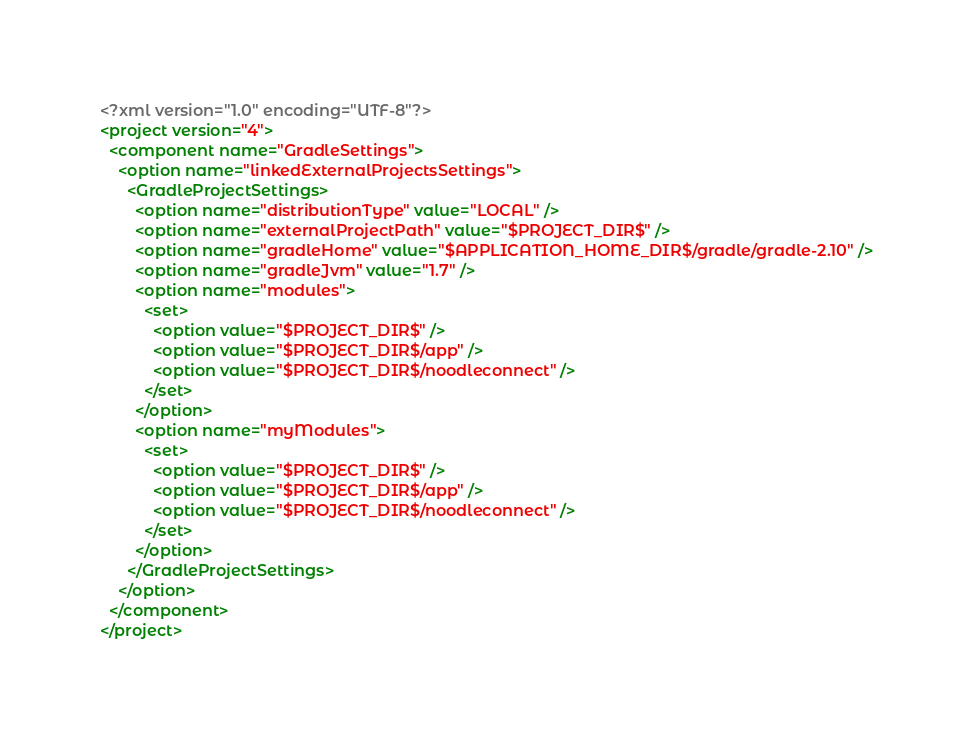<code> <loc_0><loc_0><loc_500><loc_500><_XML_><?xml version="1.0" encoding="UTF-8"?>
<project version="4">
  <component name="GradleSettings">
    <option name="linkedExternalProjectsSettings">
      <GradleProjectSettings>
        <option name="distributionType" value="LOCAL" />
        <option name="externalProjectPath" value="$PROJECT_DIR$" />
        <option name="gradleHome" value="$APPLICATION_HOME_DIR$/gradle/gradle-2.10" />
        <option name="gradleJvm" value="1.7" />
        <option name="modules">
          <set>
            <option value="$PROJECT_DIR$" />
            <option value="$PROJECT_DIR$/app" />
            <option value="$PROJECT_DIR$/noodleconnect" />
          </set>
        </option>
        <option name="myModules">
          <set>
            <option value="$PROJECT_DIR$" />
            <option value="$PROJECT_DIR$/app" />
            <option value="$PROJECT_DIR$/noodleconnect" />
          </set>
        </option>
      </GradleProjectSettings>
    </option>
  </component>
</project></code> 